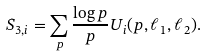Convert formula to latex. <formula><loc_0><loc_0><loc_500><loc_500>S _ { 3 , i } = \sum _ { p } \frac { \log p } { p } U _ { i } ( p , \ell _ { 1 } , \ell _ { 2 } ) .</formula> 